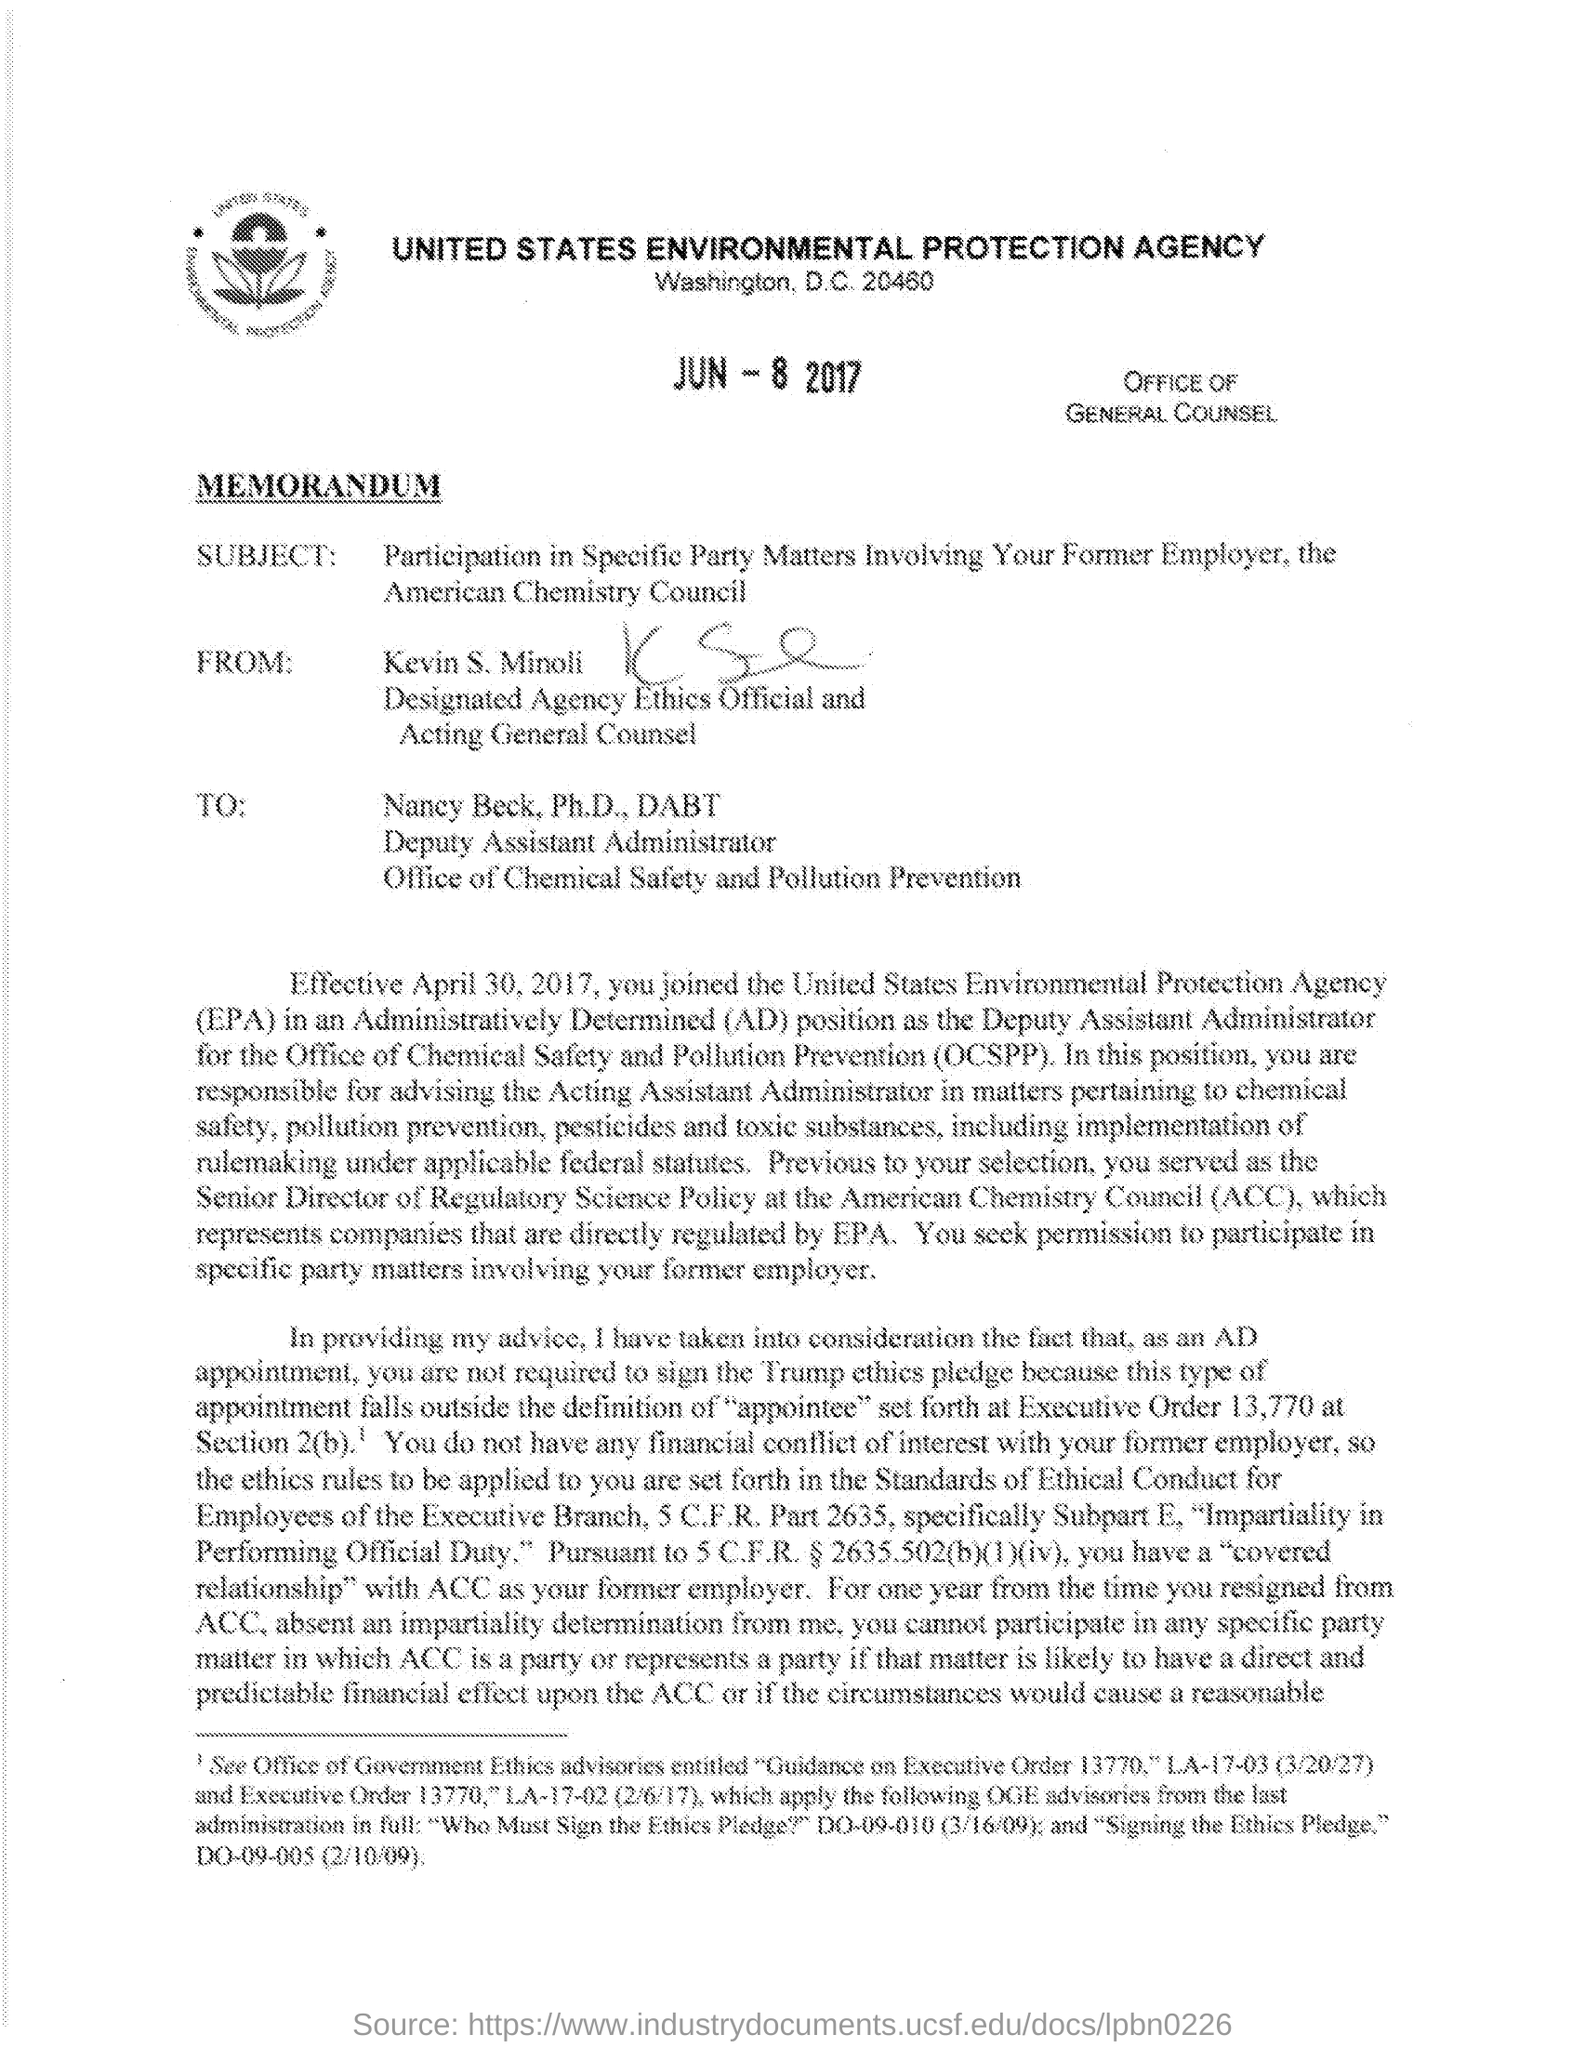What is the location of united states environmental protection agency ?
Your answer should be compact. WASHINGTON, D.C. Who is designated as agency ethics official and acting general counsel ?
Ensure brevity in your answer.  Kevin S. Minoli. What does ocspp stands for?
Offer a very short reply. OFFICE OF CHEMICAL SAFETY AND POLLUTION PREVENTION. What is the subject for this 'memorandum' ?
Your response must be concise. PARTICIPATION IN SPECIFIC PARTY MATTERS INVOLVING YOUR FORMER EMPLOYER, THE AMERICAN CHEMISTRY COUNCIL. 